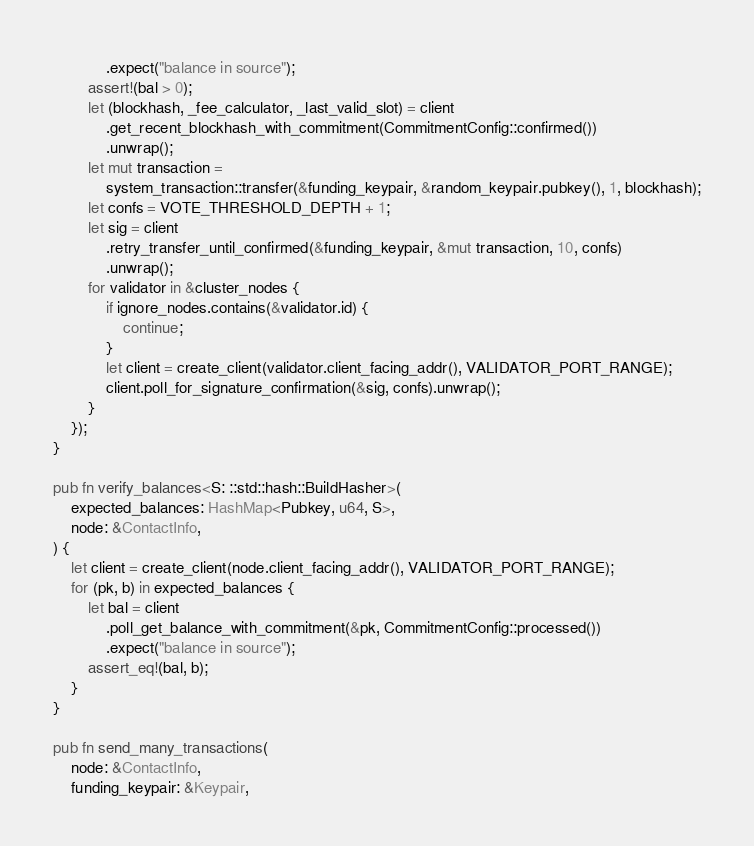Convert code to text. <code><loc_0><loc_0><loc_500><loc_500><_Rust_>            .expect("balance in source");
        assert!(bal > 0);
        let (blockhash, _fee_calculator, _last_valid_slot) = client
            .get_recent_blockhash_with_commitment(CommitmentConfig::confirmed())
            .unwrap();
        let mut transaction =
            system_transaction::transfer(&funding_keypair, &random_keypair.pubkey(), 1, blockhash);
        let confs = VOTE_THRESHOLD_DEPTH + 1;
        let sig = client
            .retry_transfer_until_confirmed(&funding_keypair, &mut transaction, 10, confs)
            .unwrap();
        for validator in &cluster_nodes {
            if ignore_nodes.contains(&validator.id) {
                continue;
            }
            let client = create_client(validator.client_facing_addr(), VALIDATOR_PORT_RANGE);
            client.poll_for_signature_confirmation(&sig, confs).unwrap();
        }
    });
}

pub fn verify_balances<S: ::std::hash::BuildHasher>(
    expected_balances: HashMap<Pubkey, u64, S>,
    node: &ContactInfo,
) {
    let client = create_client(node.client_facing_addr(), VALIDATOR_PORT_RANGE);
    for (pk, b) in expected_balances {
        let bal = client
            .poll_get_balance_with_commitment(&pk, CommitmentConfig::processed())
            .expect("balance in source");
        assert_eq!(bal, b);
    }
}

pub fn send_many_transactions(
    node: &ContactInfo,
    funding_keypair: &Keypair,</code> 